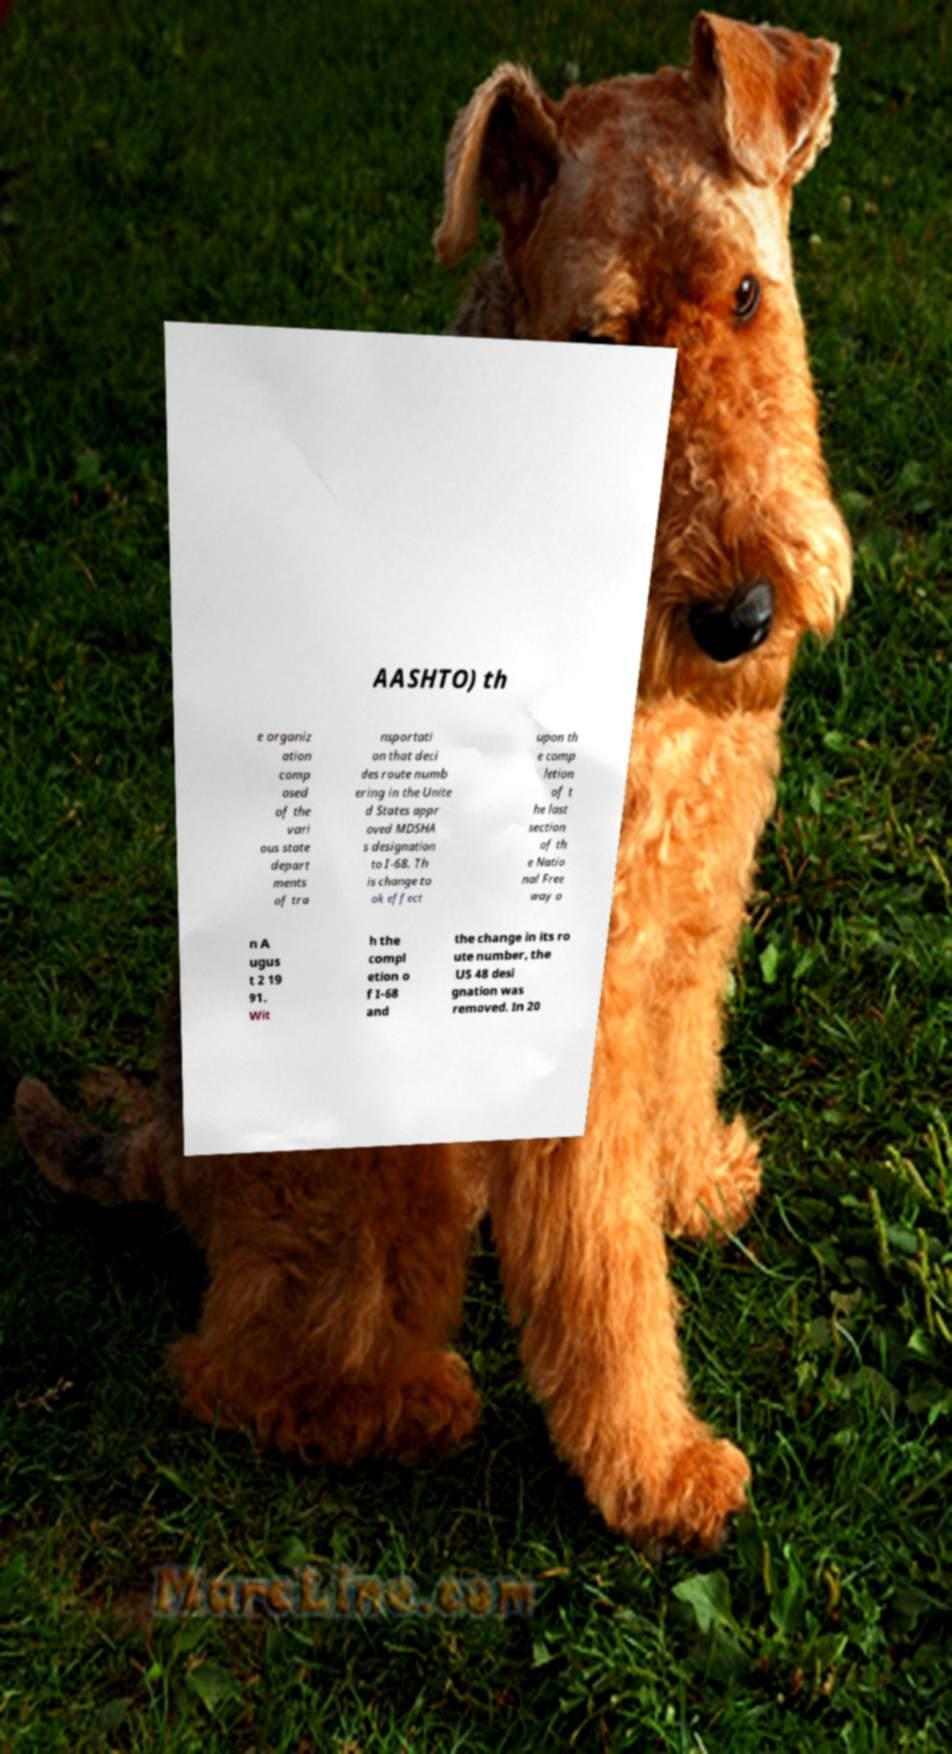Could you extract and type out the text from this image? AASHTO) th e organiz ation comp osed of the vari ous state depart ments of tra nsportati on that deci des route numb ering in the Unite d States appr oved MDSHA s designation to I-68. Th is change to ok effect upon th e comp letion of t he last section of th e Natio nal Free way o n A ugus t 2 19 91. Wit h the compl etion o f I-68 and the change in its ro ute number, the US 48 desi gnation was removed. In 20 